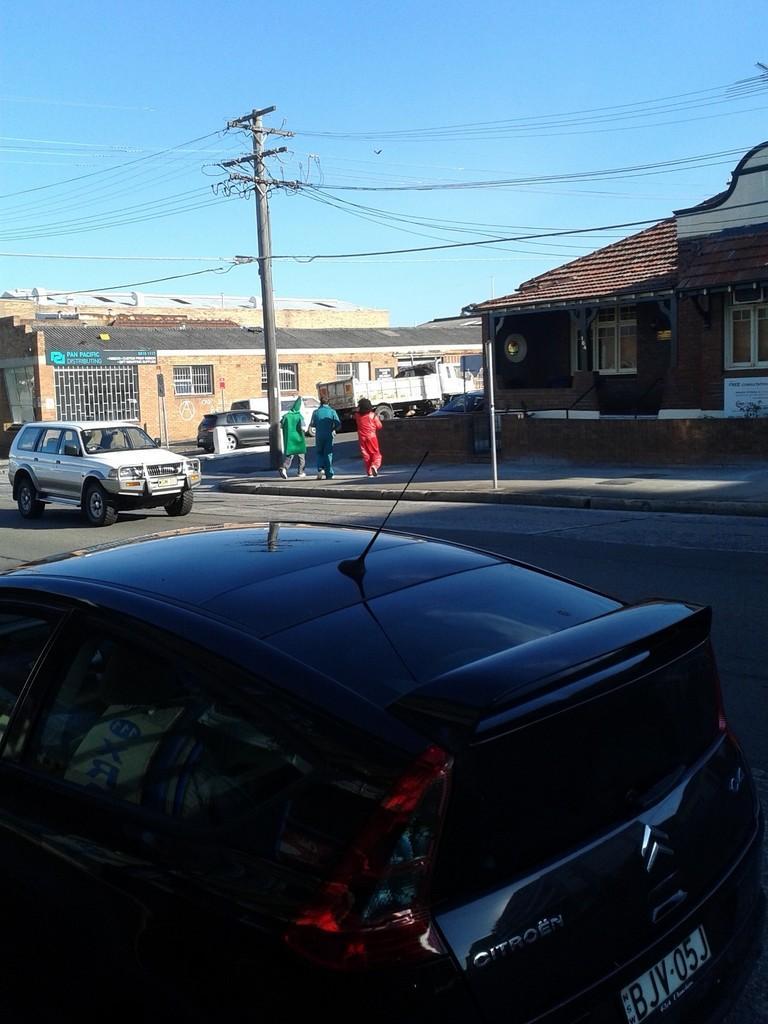Describe this image in one or two sentences. In this image there are vehicles on the road. There are people crossing the road. There is a current pole. In the background of the image there are buildings and sky. 